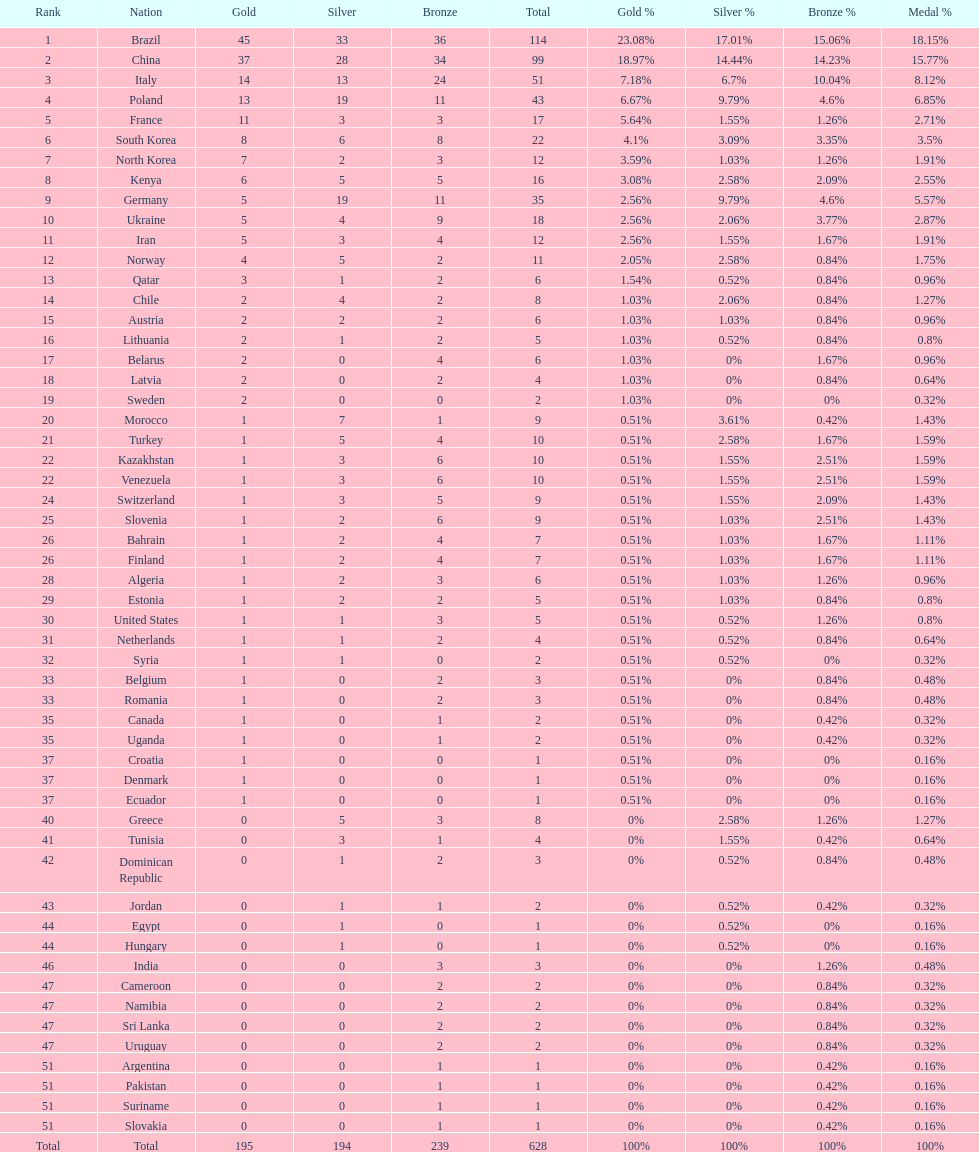How many gold medals did germany earn? 5. 